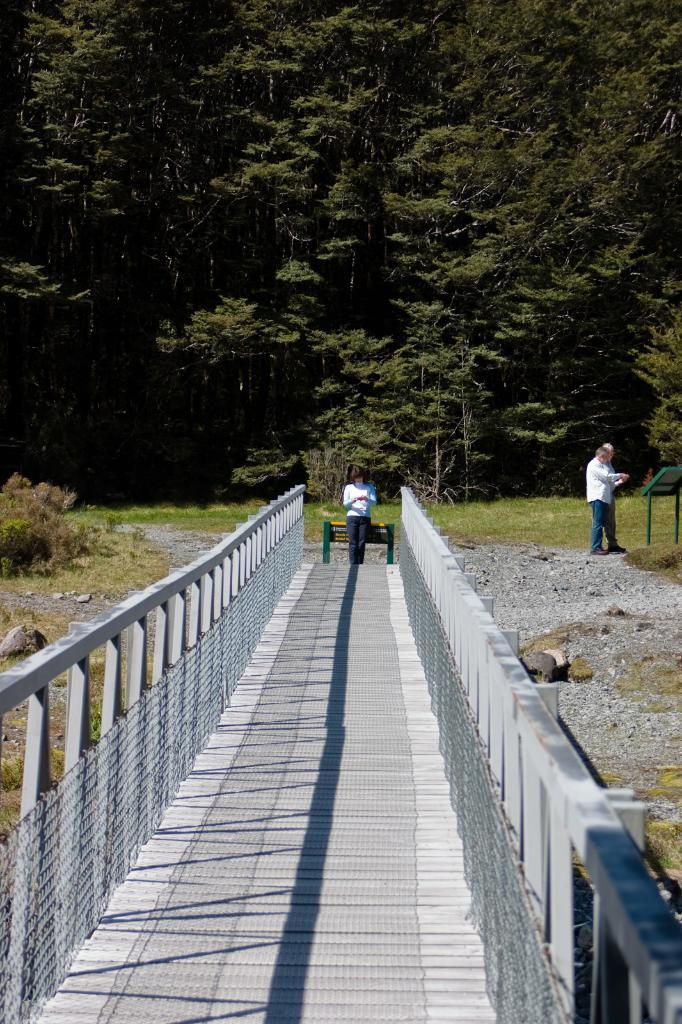How many people are in the image? There are two persons standing in the image. What are the people wearing? Both persons are wearing white shirts and blue pants. What can be seen in the background of the image? There are trees visible in the background of the image. What is the color of the trees? The trees are green in color. Can you tell me how many bases are visible in the image? There are no bases present in the image; it features two persons standing and trees in the background. Is there a tiger hiding behind the trees in the image? There is no tiger visible in the image; only trees are present in the background. 